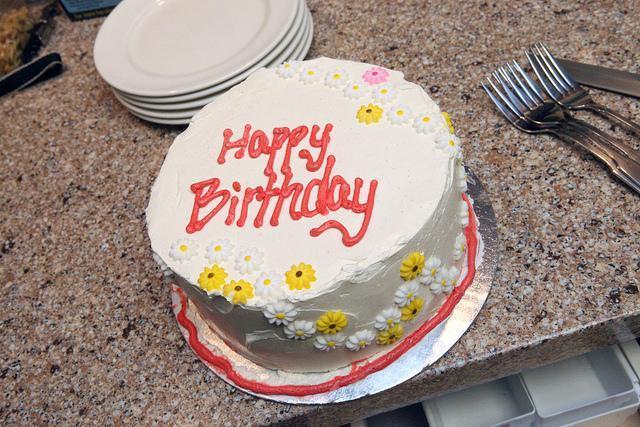How many bowls are there?
Give a very brief answer. 2. How many forks are there?
Give a very brief answer. 3. How many giraffes are looking at the camera?
Give a very brief answer. 0. 